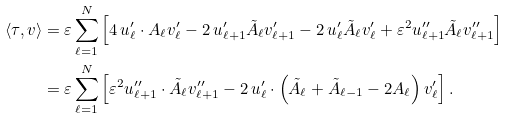Convert formula to latex. <formula><loc_0><loc_0><loc_500><loc_500>\langle \tau , v \rangle & = \varepsilon \sum _ { \ell = 1 } ^ { N } \left [ 4 \, u ^ { \prime } _ { \ell } \cdot A _ { \ell } v ^ { \prime } _ { \ell } - 2 \, u ^ { \prime } _ { \ell + 1 } \tilde { A } _ { \ell } v ^ { \prime } _ { \ell + 1 } - 2 \, u ^ { \prime } _ { \ell } \tilde { A } _ { \ell } v ^ { \prime } _ { \ell } + \varepsilon ^ { 2 } u ^ { \prime \prime } _ { \ell + 1 } \tilde { A } _ { \ell } v ^ { \prime \prime } _ { \ell + 1 } \right ] \\ & = \varepsilon \sum _ { \ell = 1 } ^ { N } \left [ \varepsilon ^ { 2 } u ^ { \prime \prime } _ { \ell + 1 } \cdot \tilde { A } _ { \ell } v ^ { \prime \prime } _ { \ell + 1 } - 2 \, u ^ { \prime } _ { \ell } \cdot \left ( \tilde { A } _ { \ell } + \tilde { A } _ { \ell - 1 } - 2 A _ { \ell } \right ) v ^ { \prime } _ { \ell } \right ] .</formula> 